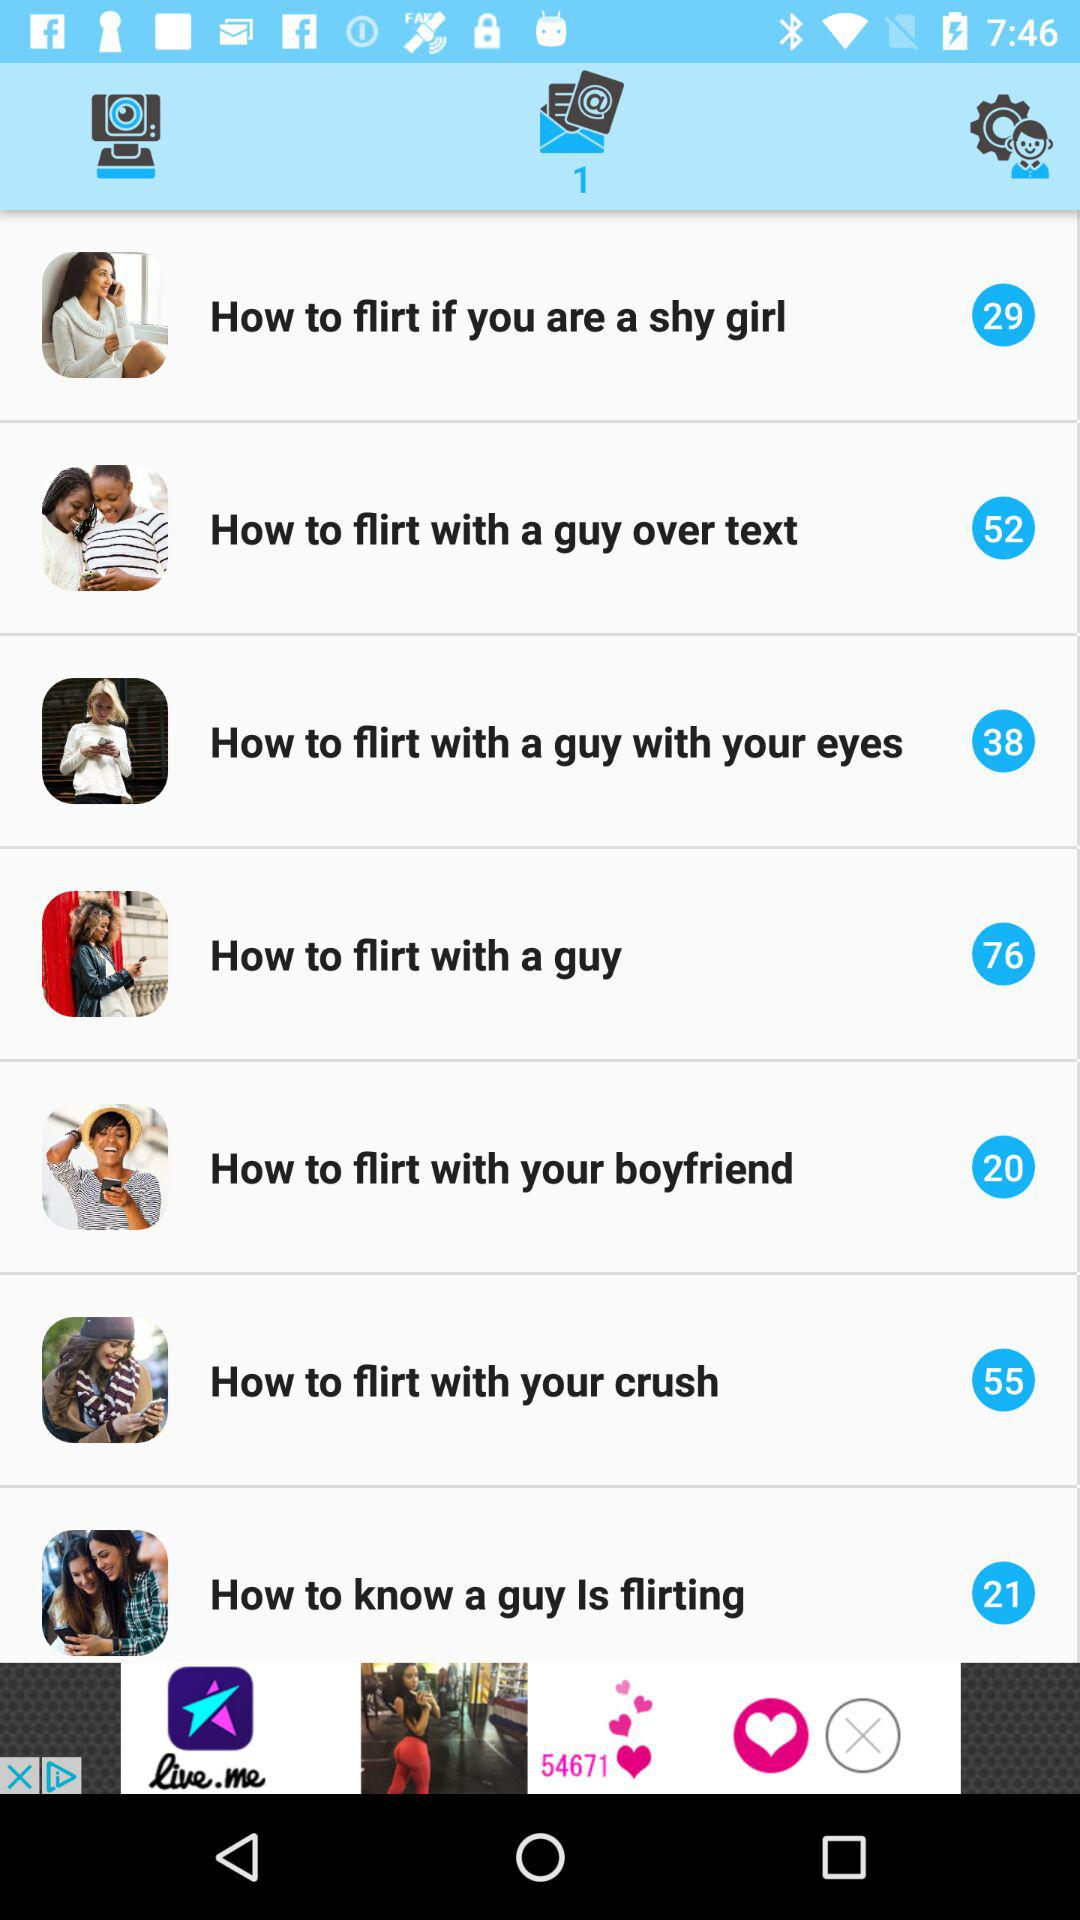What is the number of tips on the topic "How to flirt if you are a shy girl"? The number of tips on the topic "How to flirt if you are a shy girl" is 29. 